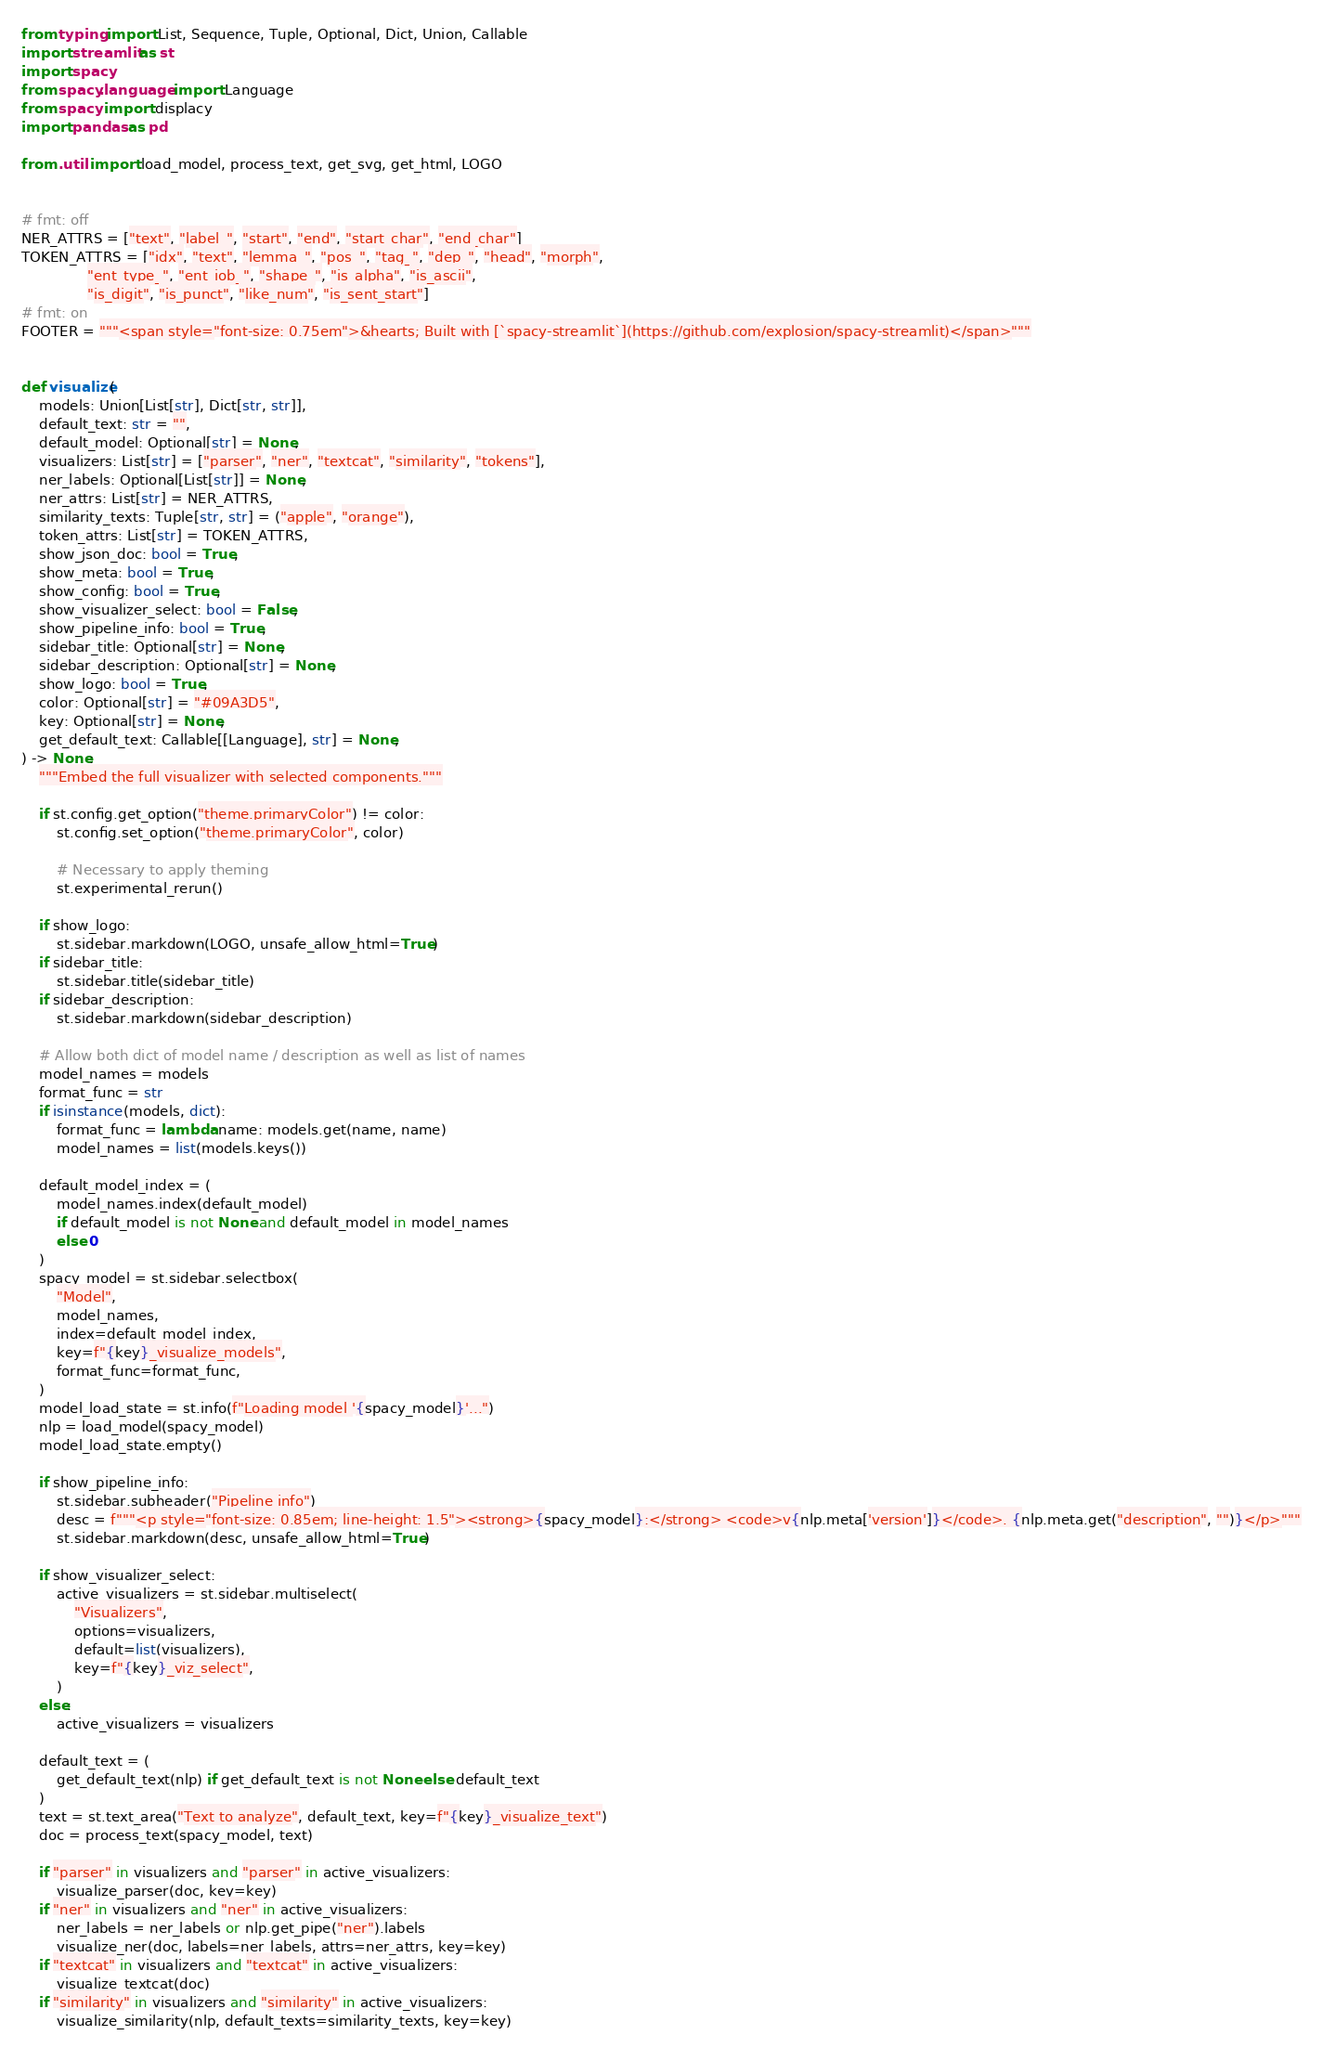<code> <loc_0><loc_0><loc_500><loc_500><_Python_>from typing import List, Sequence, Tuple, Optional, Dict, Union, Callable
import streamlit as st
import spacy
from spacy.language import Language
from spacy import displacy
import pandas as pd

from .util import load_model, process_text, get_svg, get_html, LOGO


# fmt: off
NER_ATTRS = ["text", "label_", "start", "end", "start_char", "end_char"]
TOKEN_ATTRS = ["idx", "text", "lemma_", "pos_", "tag_", "dep_", "head", "morph",
               "ent_type_", "ent_iob_", "shape_", "is_alpha", "is_ascii",
               "is_digit", "is_punct", "like_num", "is_sent_start"]
# fmt: on
FOOTER = """<span style="font-size: 0.75em">&hearts; Built with [`spacy-streamlit`](https://github.com/explosion/spacy-streamlit)</span>"""


def visualize(
    models: Union[List[str], Dict[str, str]],
    default_text: str = "",
    default_model: Optional[str] = None,
    visualizers: List[str] = ["parser", "ner", "textcat", "similarity", "tokens"],
    ner_labels: Optional[List[str]] = None,
    ner_attrs: List[str] = NER_ATTRS,
    similarity_texts: Tuple[str, str] = ("apple", "orange"),
    token_attrs: List[str] = TOKEN_ATTRS,
    show_json_doc: bool = True,
    show_meta: bool = True,
    show_config: bool = True,
    show_visualizer_select: bool = False,
    show_pipeline_info: bool = True,
    sidebar_title: Optional[str] = None,
    sidebar_description: Optional[str] = None,
    show_logo: bool = True,
    color: Optional[str] = "#09A3D5",
    key: Optional[str] = None,
    get_default_text: Callable[[Language], str] = None,
) -> None:
    """Embed the full visualizer with selected components."""

    if st.config.get_option("theme.primaryColor") != color:
        st.config.set_option("theme.primaryColor", color)

        # Necessary to apply theming
        st.experimental_rerun()

    if show_logo:
        st.sidebar.markdown(LOGO, unsafe_allow_html=True)
    if sidebar_title:
        st.sidebar.title(sidebar_title)
    if sidebar_description:
        st.sidebar.markdown(sidebar_description)

    # Allow both dict of model name / description as well as list of names
    model_names = models
    format_func = str
    if isinstance(models, dict):
        format_func = lambda name: models.get(name, name)
        model_names = list(models.keys())

    default_model_index = (
        model_names.index(default_model)
        if default_model is not None and default_model in model_names
        else 0
    )
    spacy_model = st.sidebar.selectbox(
        "Model",
        model_names,
        index=default_model_index,
        key=f"{key}_visualize_models",
        format_func=format_func,
    )
    model_load_state = st.info(f"Loading model '{spacy_model}'...")
    nlp = load_model(spacy_model)
    model_load_state.empty()

    if show_pipeline_info:
        st.sidebar.subheader("Pipeline info")
        desc = f"""<p style="font-size: 0.85em; line-height: 1.5"><strong>{spacy_model}:</strong> <code>v{nlp.meta['version']}</code>. {nlp.meta.get("description", "")}</p>"""
        st.sidebar.markdown(desc, unsafe_allow_html=True)

    if show_visualizer_select:
        active_visualizers = st.sidebar.multiselect(
            "Visualizers",
            options=visualizers,
            default=list(visualizers),
            key=f"{key}_viz_select",
        )
    else:
        active_visualizers = visualizers

    default_text = (
        get_default_text(nlp) if get_default_text is not None else default_text
    )
    text = st.text_area("Text to analyze", default_text, key=f"{key}_visualize_text")
    doc = process_text(spacy_model, text)

    if "parser" in visualizers and "parser" in active_visualizers:
        visualize_parser(doc, key=key)
    if "ner" in visualizers and "ner" in active_visualizers:
        ner_labels = ner_labels or nlp.get_pipe("ner").labels
        visualize_ner(doc, labels=ner_labels, attrs=ner_attrs, key=key)
    if "textcat" in visualizers and "textcat" in active_visualizers:
        visualize_textcat(doc)
    if "similarity" in visualizers and "similarity" in active_visualizers:
        visualize_similarity(nlp, default_texts=similarity_texts, key=key)</code> 